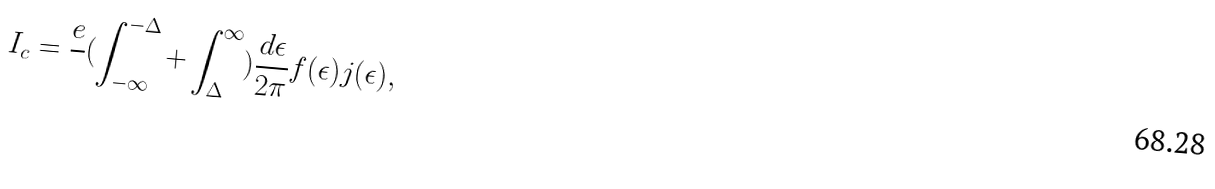<formula> <loc_0><loc_0><loc_500><loc_500>I _ { c } = \frac { e } { } ( \int _ { - \infty } ^ { - \Delta } + \int _ { \Delta } ^ { \infty } ) \frac { d \epsilon } { 2 \pi } f ( \epsilon ) j ( \epsilon ) ,</formula> 